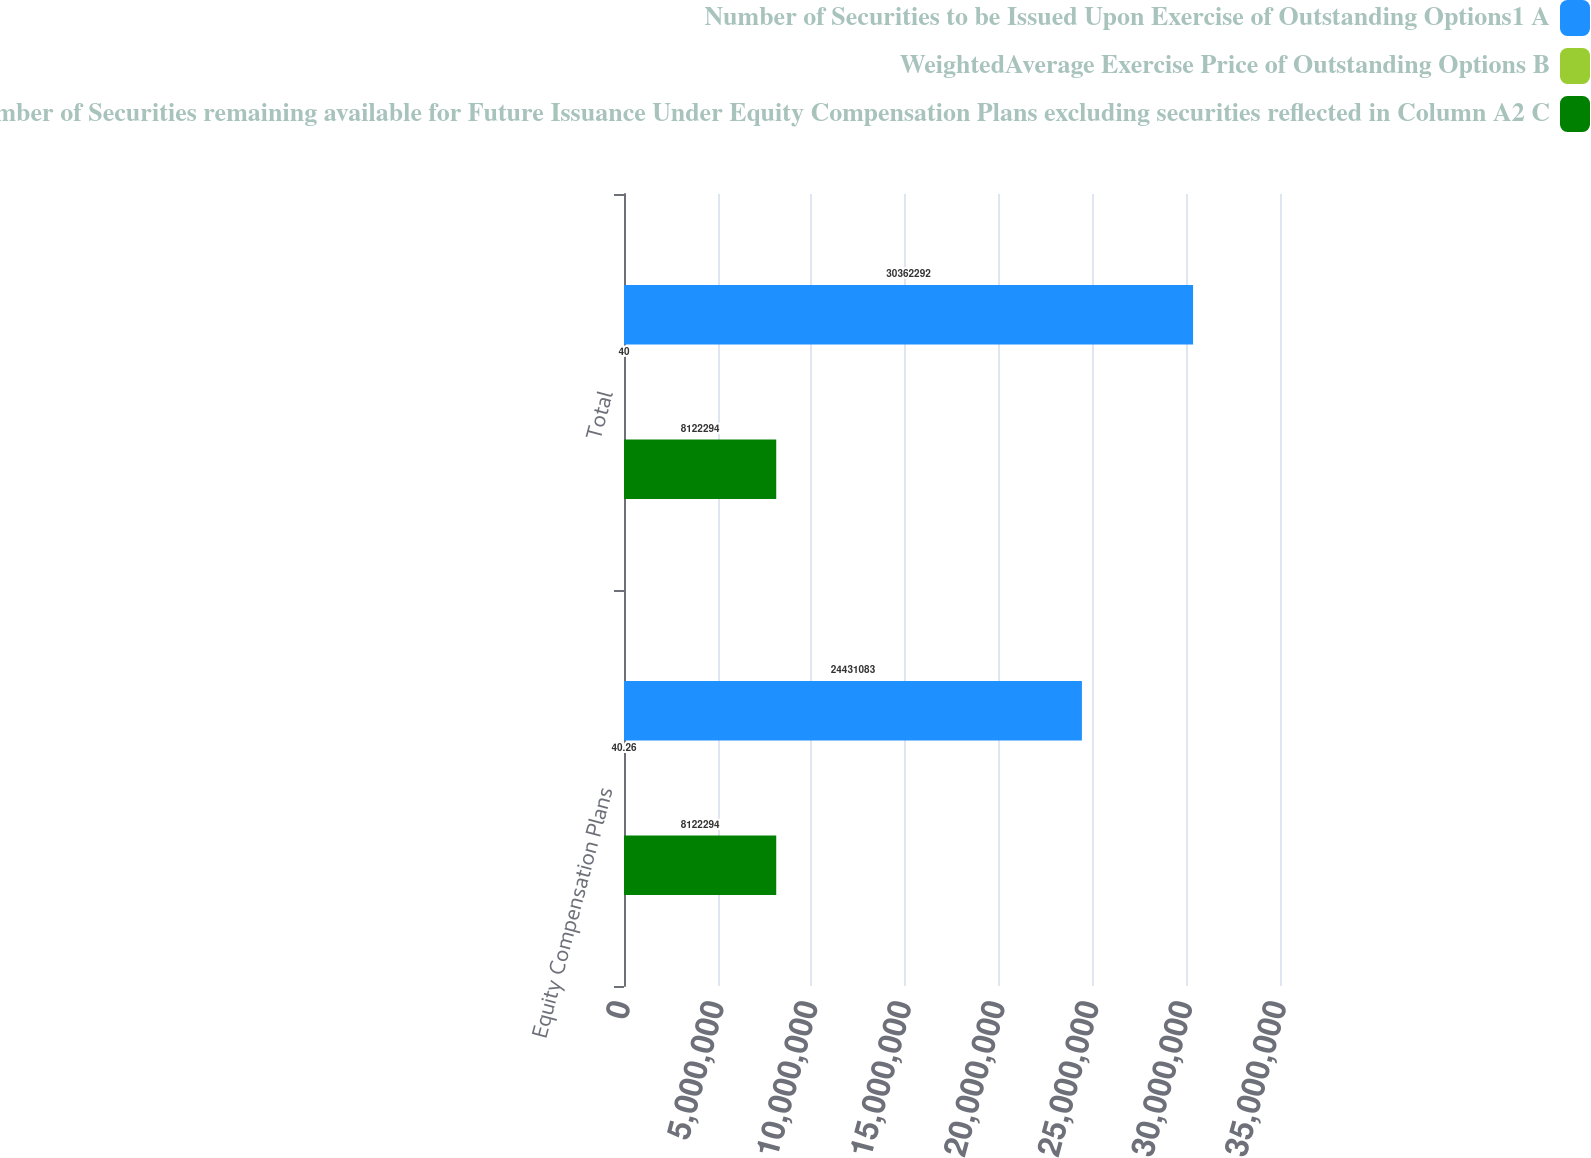Convert chart. <chart><loc_0><loc_0><loc_500><loc_500><stacked_bar_chart><ecel><fcel>Equity Compensation Plans<fcel>Total<nl><fcel>Number of Securities to be Issued Upon Exercise of Outstanding Options1 A<fcel>2.44311e+07<fcel>3.03623e+07<nl><fcel>WeightedAverage Exercise Price of Outstanding Options B<fcel>40.26<fcel>40<nl><fcel>Number of Securities remaining available for Future Issuance Under Equity Compensation Plans excluding securities reflected in Column A2 C<fcel>8.12229e+06<fcel>8.12229e+06<nl></chart> 